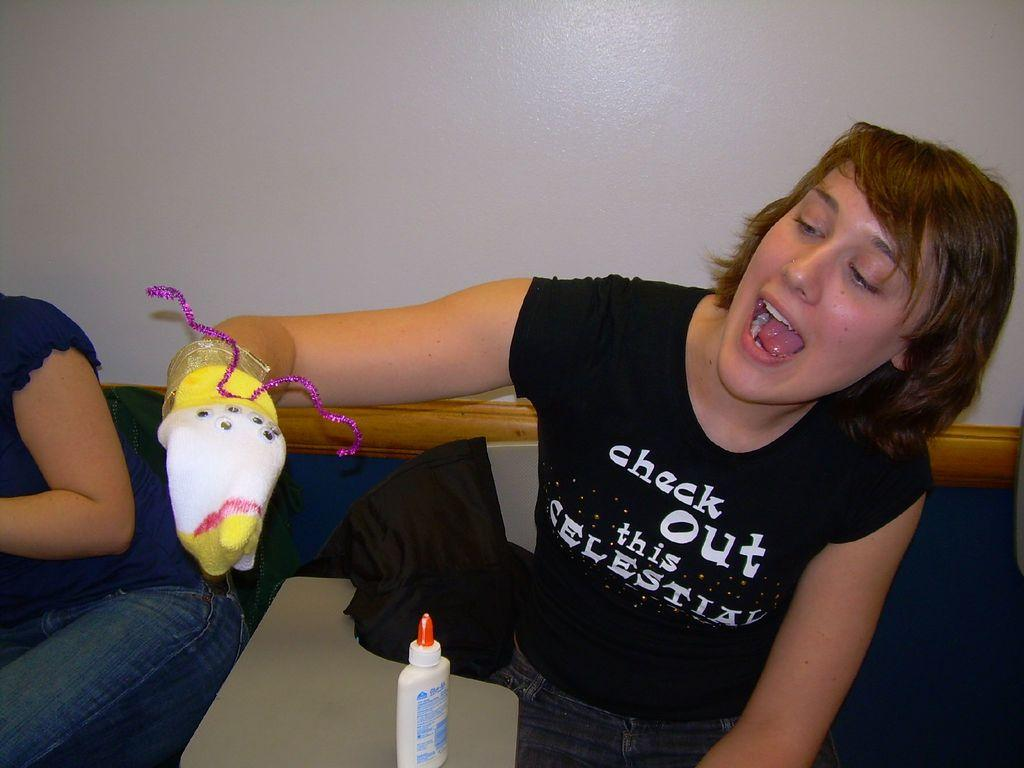What are the persons in the image doing? The persons in the image are sitting on a bench. Can you describe the clothing or accessories of one of the persons? One of the persons is wearing gloves on their hands. What can be seen in the background of the image? Walls are visible in the background of the image. What object is present on a desk in the background? There is a glue bottle on a desk in the background of the image. What type of oatmeal is being served to the servant in the image? There is no servant or oatmeal present in the image. What is the color of the bottle in the image? The provided facts do not mention the color of the glue bottle, so it cannot be determined from the image. 